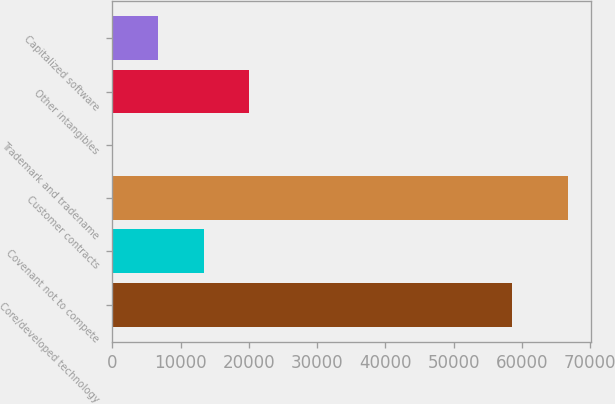<chart> <loc_0><loc_0><loc_500><loc_500><bar_chart><fcel>Core/developed technology<fcel>Covenant not to compete<fcel>Customer contracts<fcel>Trademark and tradename<fcel>Other intangibles<fcel>Capitalized software<nl><fcel>58562<fcel>13396.6<fcel>66815<fcel>42<fcel>20073.9<fcel>6719.3<nl></chart> 